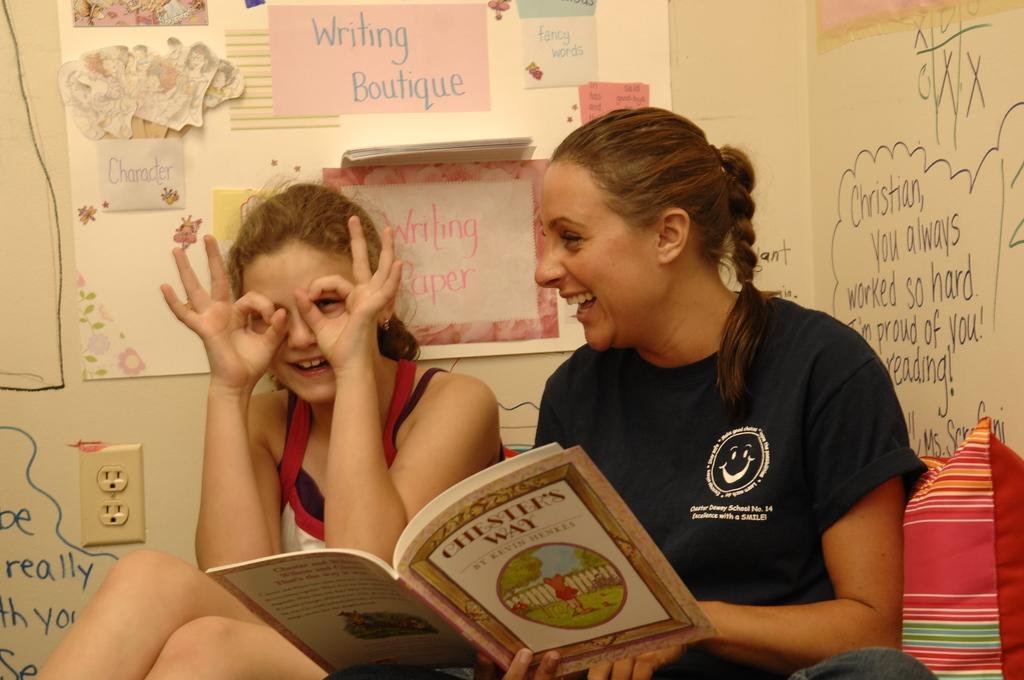How many people are in the image? There are two persons in the image. What are the people doing in the image? The people are smiling in the image. Who is holding a book in the image? There is a person holding a book in the image. What can be seen on the board in the image? There are papers on the board in the image. What is written or drawn on the wall in the image? There are scribblings on the wall in the image. What historical event is being discussed in the image? There is no indication of a historical event being discussed in the image. What day of the week is depicted in the image? The day of the week is not visible or mentioned in the image. 